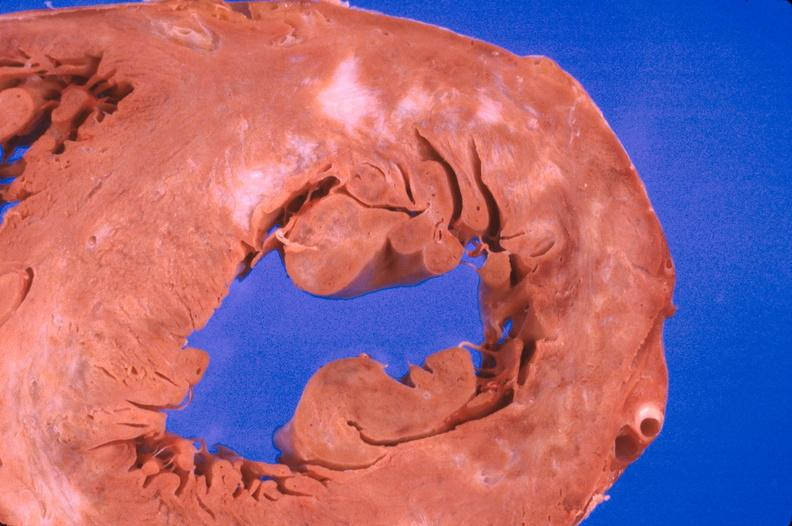what is present?
Answer the question using a single word or phrase. Cardiovascular 